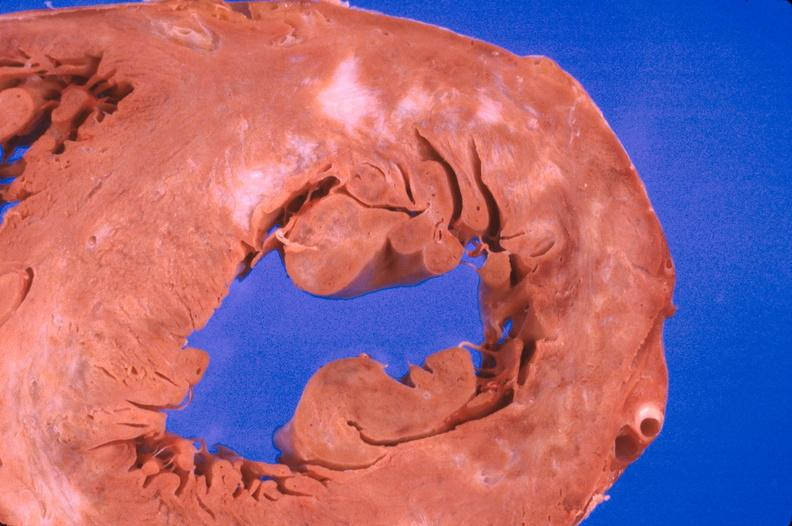what is present?
Answer the question using a single word or phrase. Cardiovascular 